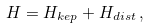Convert formula to latex. <formula><loc_0><loc_0><loc_500><loc_500>H = H _ { k e p } + H _ { d i s t } \, ,</formula> 